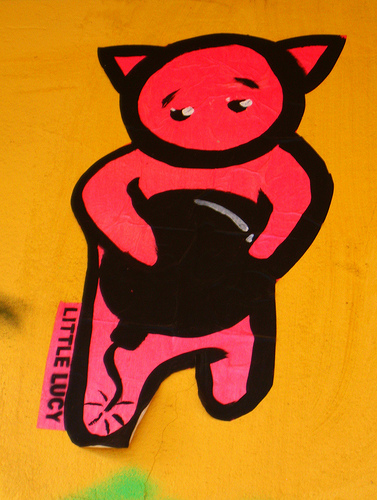<image>
Is there a cat behind the table? No. The cat is not behind the table. From this viewpoint, the cat appears to be positioned elsewhere in the scene. 